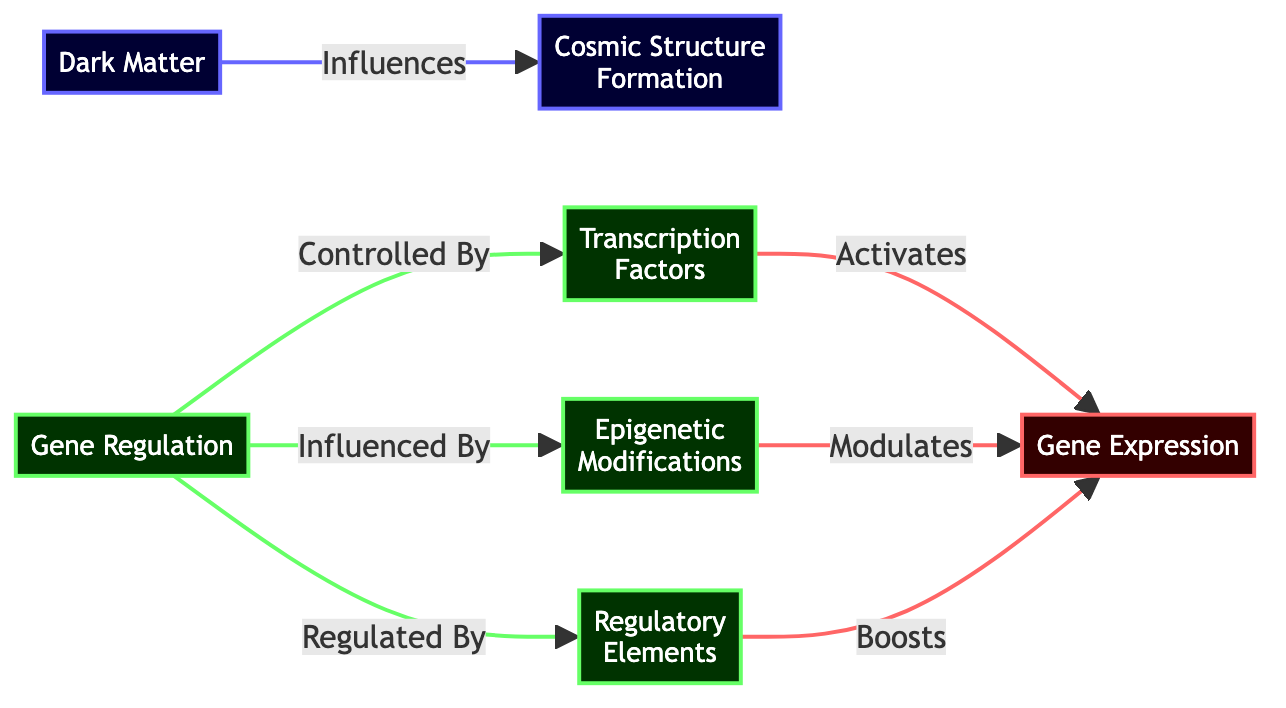What is the influence of Dark Matter on Cosmic Structure Formation? The diagram illustrates that Dark Matter directly influences Cosmic Structure Formation, represented by a directed edge from the Dark Matter node to the Cosmic Structure Formation node.
Answer: Influences How many regulatory mechanisms are shown in relation to Gene Regulation? There are three mechanisms listed that influence Gene Regulation: Transcription Factors, Epigenetic Modifications, and Regulatory Elements, as shown in the diagram connected to the Gene Regulation node.
Answer: 3 Which element boosts Gene Expression? According to the diagram, Regulatory Elements boost Gene Expression, as indicated by a directed edge from the Regulatory Elements node to the Gene Expression node.
Answer: Boosts What role do Epigenetic Modifications play in Gene Regulation? The diagram indicates that Epigenetic Modifications influence Gene Regulation, as shown by the edge that connects the Epigenetic Modifications node to the Gene Regulation node.
Answer: Influences Describe the relationship between Transcription Factors and Gene Expression. The diagram shows that Transcription Factors activate Gene Expression, illustrated by the directed edge from the Transcription Factors node to the Gene Expression node.
Answer: Activates How many nodes are classified under gene mechanisms? The diagram displays three nodes that fall under gene mechanisms: Transcription Factors, Epigenetic Modifications, and Regulatory Elements, classified distinctly by the geneClass style.
Answer: 3 What is the connection between Cosmic Structure Formation and Gene Regulation? The diagram does not explicitly show a direct connection between Cosmic Structure Formation and Gene Regulation. However, it emphasizes the influence of Dark Matter on Cosmic Structure Formation without linking it to Gene Regulation.
Answer: None Which component in gene regulation modulates Gene Expression? The diagram indicates that Epigenetic Modifications modulate Gene Expression, as represented by the edge leading from the Epigenetic Modifications node to the Gene Expression node.
Answer: Modulates What is the main theme visualized in this diagram? The diagram presents a theme that combines astrophysical concepts, particularly Dark Matter's influence on Cosmic Structure Formation, with biological concepts, specifically Gene Regulation mechanisms.
Answer: Dark Matter and Gene Regulation 